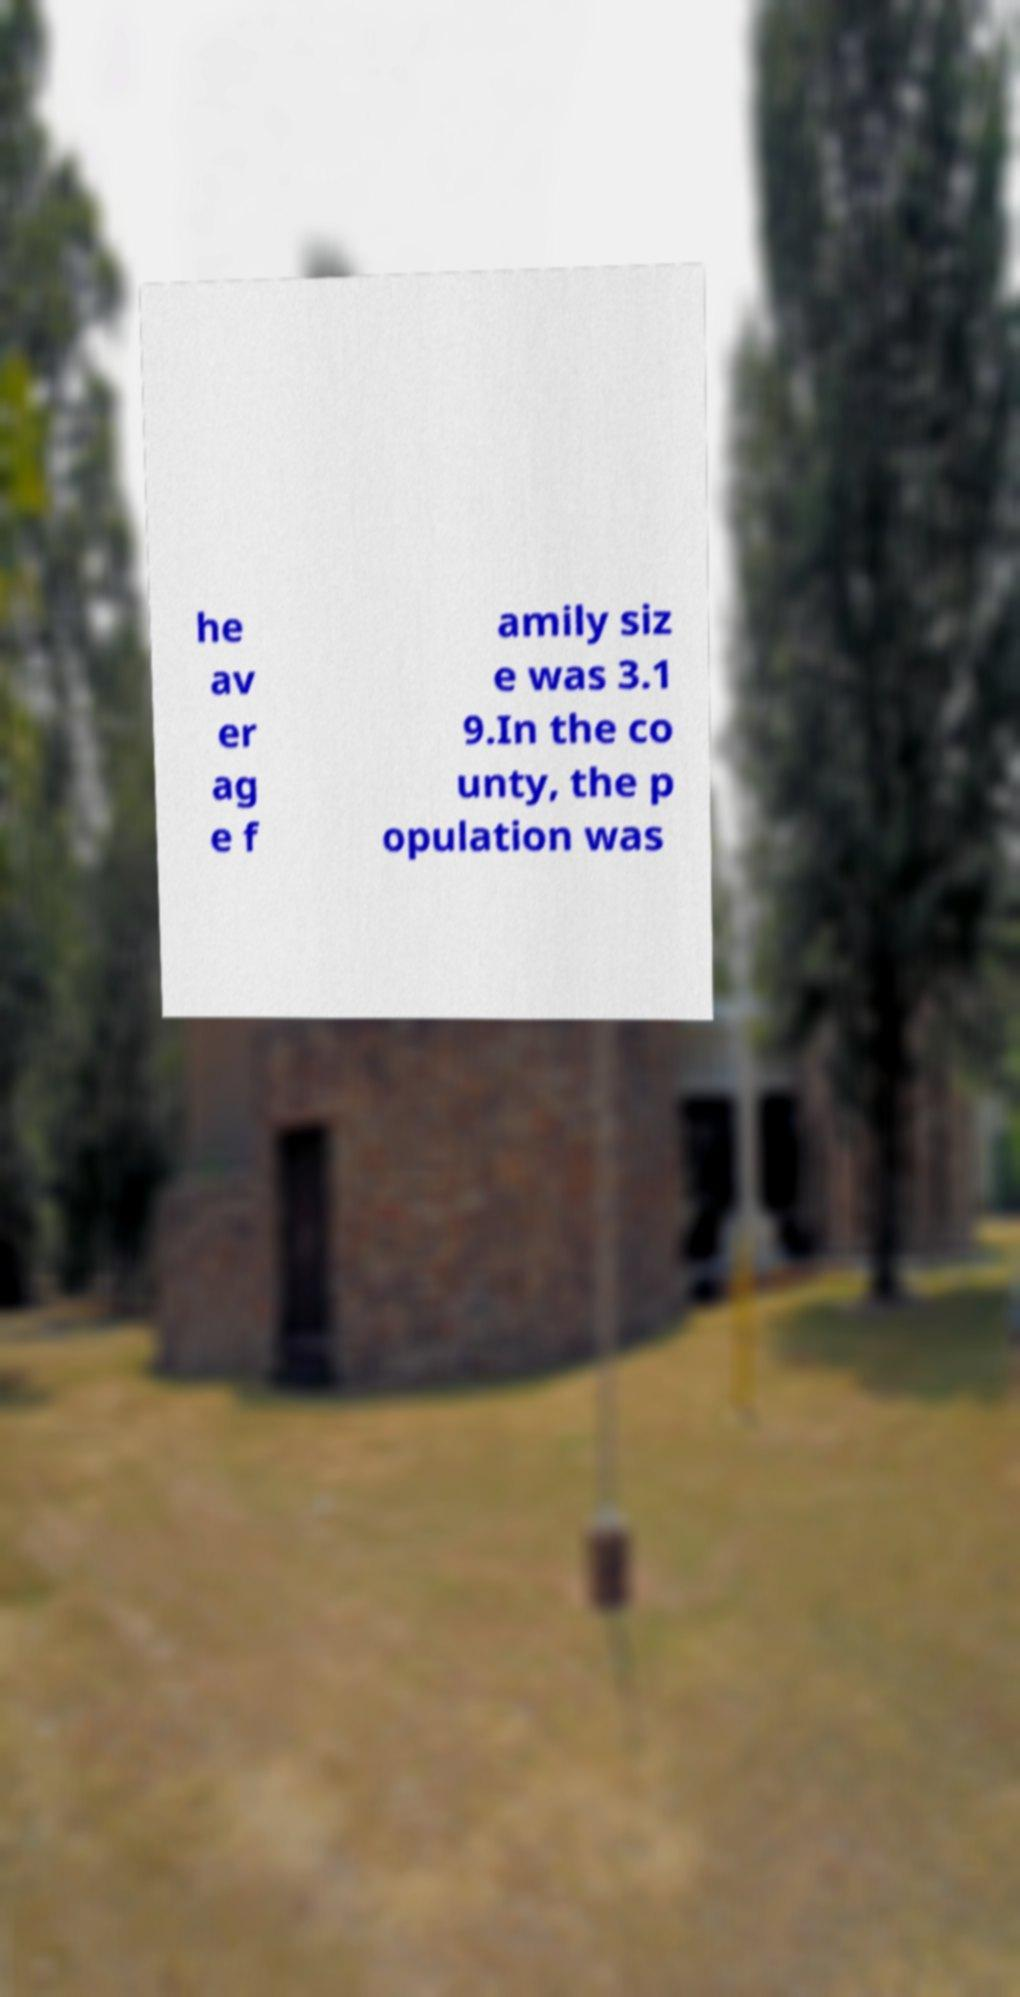There's text embedded in this image that I need extracted. Can you transcribe it verbatim? he av er ag e f amily siz e was 3.1 9.In the co unty, the p opulation was 